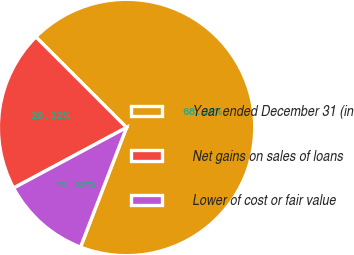<chart> <loc_0><loc_0><loc_500><loc_500><pie_chart><fcel>Year ended December 31 (in<fcel>Net gains on sales of loans<fcel>Lower of cost or fair value<nl><fcel>68.36%<fcel>20.32%<fcel>11.32%<nl></chart> 